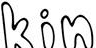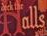What words are shown in these images in order, separated by a semicolon? kin; Halls 